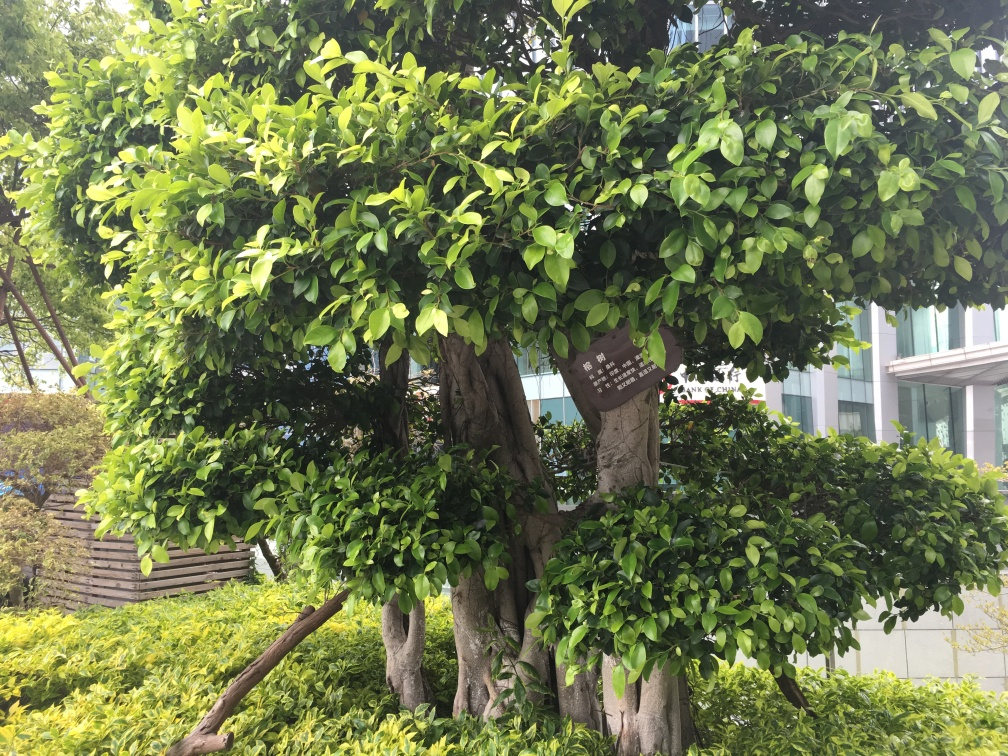Can you tell me what time of day it might be, based on the lighting in the image? Based on the softness and angle of the shadows under the tree, it suggests that the photo might have been taken in the early morning or late afternoon, when the sun is not at its peak, resulting in a gentle illumination. 